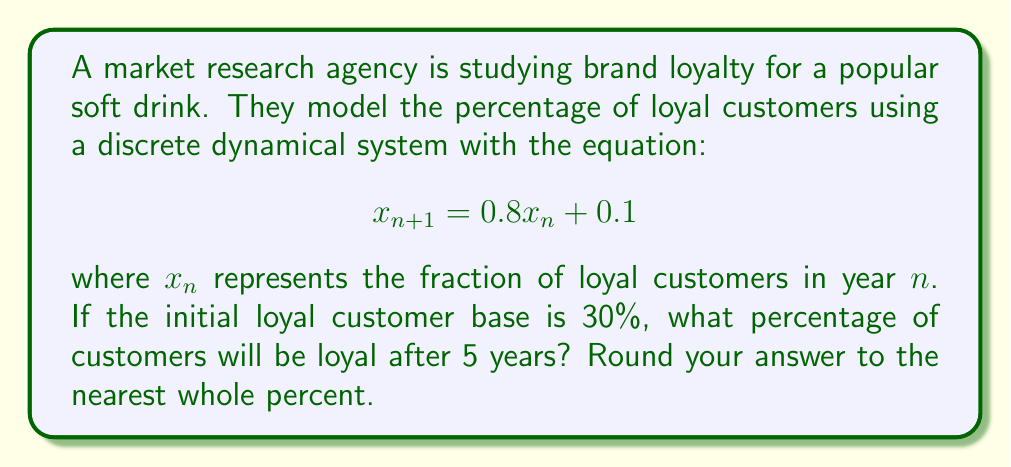Could you help me with this problem? To solve this problem, we need to iterate the given equation for 5 years:

1) Start with $x_0 = 0.30$ (30% initial loyal customers)

2) Calculate for each year:
   Year 1: $x_1 = 0.8(0.30) + 0.1 = 0.34$
   Year 2: $x_2 = 0.8(0.34) + 0.1 = 0.372$
   Year 3: $x_3 = 0.8(0.372) + 0.1 = 0.3976$
   Year 4: $x_4 = 0.8(0.3976) + 0.1 = 0.41808$
   Year 5: $x_5 = 0.8(0.41808) + 0.1 = 0.434464$

3) Convert to percentage: $0.434464 * 100 = 43.4464\%$

4) Round to the nearest whole percent: $43\%$
Answer: 43% 